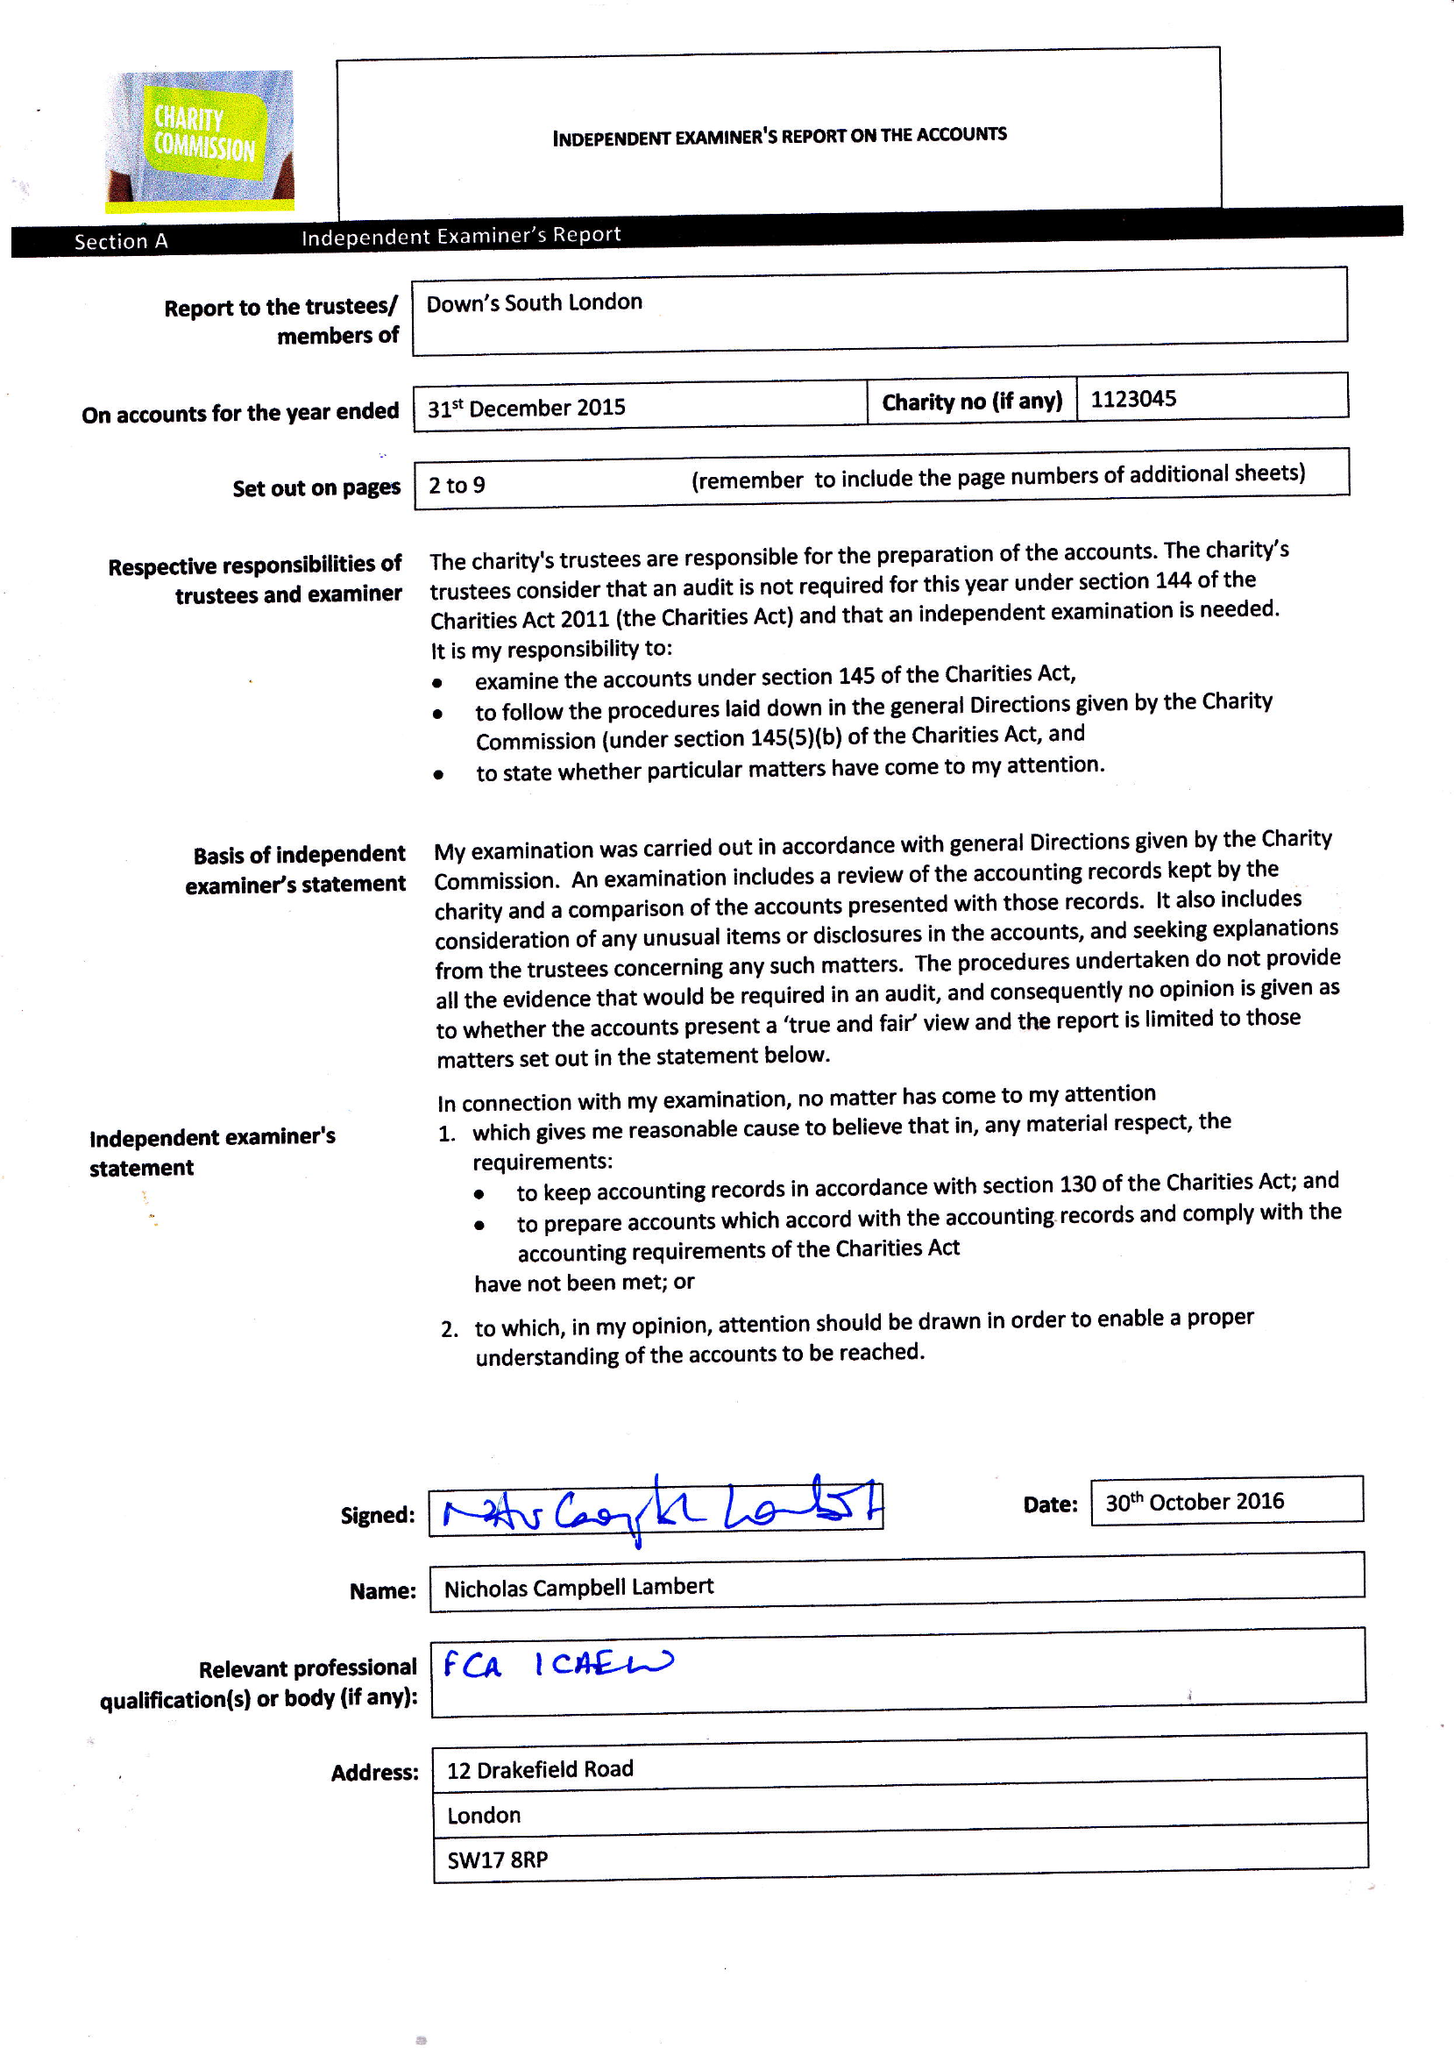What is the value for the income_annually_in_british_pounds?
Answer the question using a single word or phrase. 111389.00 